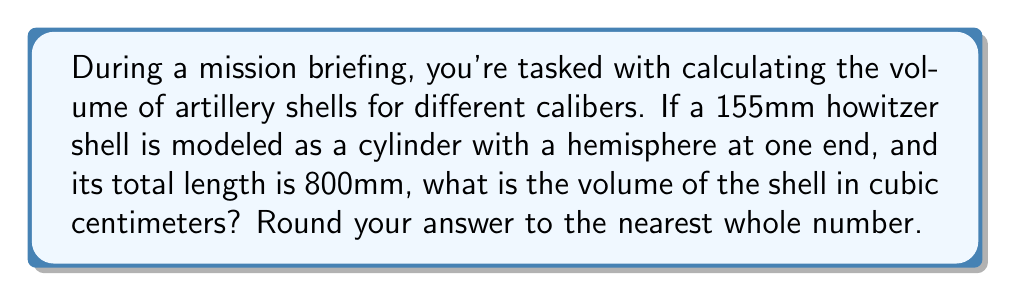Can you solve this math problem? Let's approach this step-by-step:

1) First, we need to understand the shape. It's a cylinder with a hemisphere at one end. The diameter of both the cylinder and hemisphere is 155mm.

2) Let's define our variables:
   $r$ = radius of the shell = 155mm / 2 = 77.5mm
   $L$ = total length of the shell = 800mm
   $h$ = height of the cylindrical part

3) The length of the cylindrical part (h) will be the total length minus the radius:
   $h = L - r = 800 - 77.5 = 722.5$ mm

4) Now, we can calculate the volume in two parts:

   a) Volume of the cylinder: $V_{cylinder} = \pi r^2 h$
   b) Volume of the hemisphere: $V_{hemisphere} = \frac{2}{3}\pi r^3$

5) Let's calculate:
   $V_{cylinder} = \pi (77.5)^2 (722.5) = 13,625,241.15$ mm³
   $V_{hemisphere} = \frac{2}{3}\pi (77.5)^3 = 973,231.51$ mm³

6) Total volume:
   $V_{total} = V_{cylinder} + V_{hemisphere} = 13,625,241.15 + 973,231.51 = 14,598,472.66$ mm³

7) Converting to cm³:
   $14,598,472.66$ mm³ = $14,598.47$ cm³

8) Rounding to the nearest whole number:
   $14,598$ cm³
Answer: 14,598 cm³ 